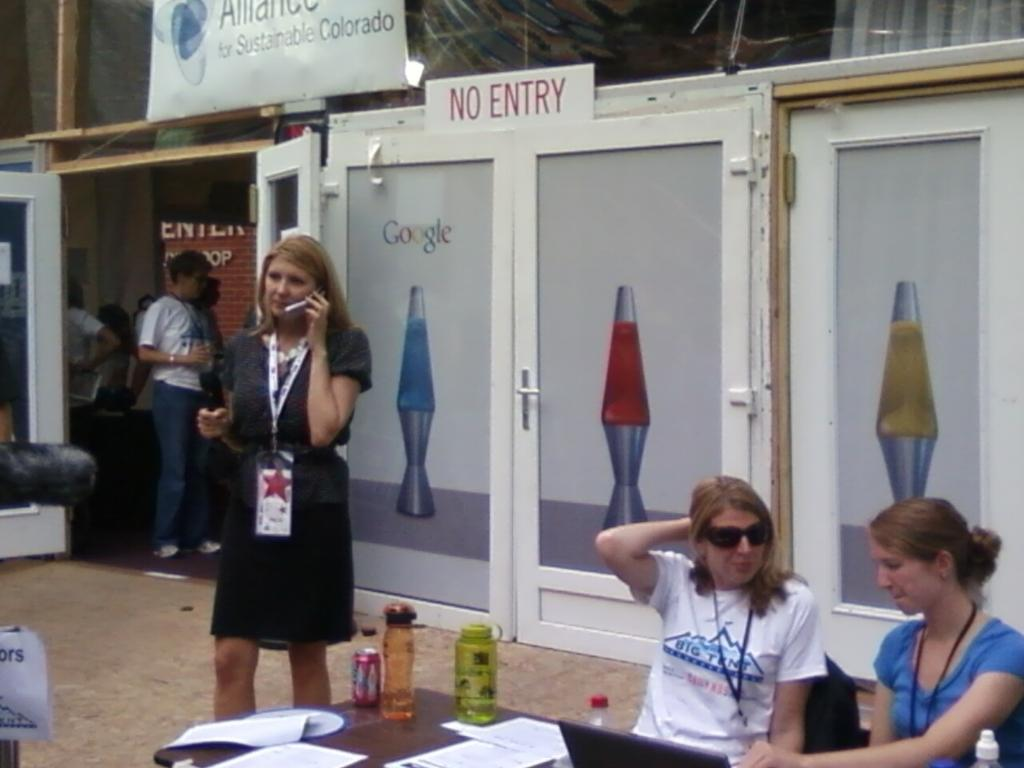How many people are in the image? There are persons in the image, but the exact number is not specified. What is present on the table in the image? There are bottles, a tin, and papers on the table in the image. What can be seen in the background of the image? There are doors and boards in the background of the image. Can you see any icicles hanging from the boards in the background? There are no icicles present in the image; it features a table with objects and a background with doors and boards. Is there any indication of hate between the persons in the image? The image does not provide any information about the relationships or emotions between the persons, so it is not possible to determine if there is any hate present. 